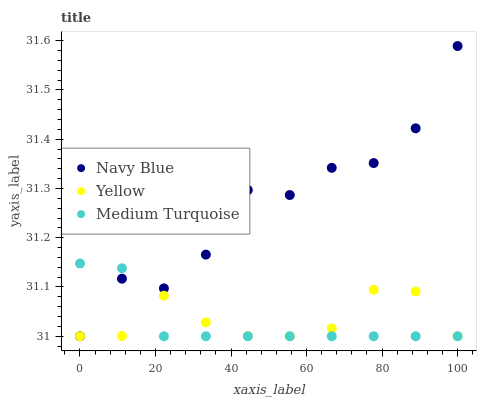Does Medium Turquoise have the minimum area under the curve?
Answer yes or no. Yes. Does Navy Blue have the maximum area under the curve?
Answer yes or no. Yes. Does Yellow have the minimum area under the curve?
Answer yes or no. No. Does Yellow have the maximum area under the curve?
Answer yes or no. No. Is Medium Turquoise the smoothest?
Answer yes or no. Yes. Is Navy Blue the roughest?
Answer yes or no. Yes. Is Yellow the smoothest?
Answer yes or no. No. Is Yellow the roughest?
Answer yes or no. No. Does Navy Blue have the lowest value?
Answer yes or no. Yes. Does Navy Blue have the highest value?
Answer yes or no. Yes. Does Medium Turquoise have the highest value?
Answer yes or no. No. Does Yellow intersect Medium Turquoise?
Answer yes or no. Yes. Is Yellow less than Medium Turquoise?
Answer yes or no. No. Is Yellow greater than Medium Turquoise?
Answer yes or no. No. 